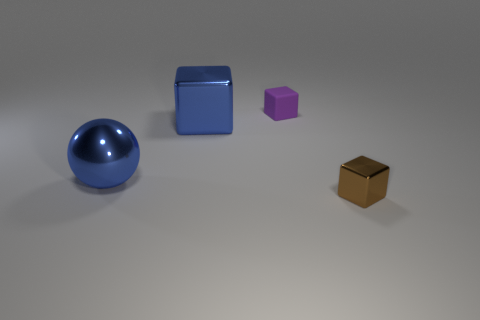Add 2 small cyan cubes. How many objects exist? 6 Subtract all large blocks. How many blocks are left? 2 Subtract 2 cubes. How many cubes are left? 1 Subtract all purple cubes. How many cubes are left? 2 Subtract all cubes. How many objects are left? 1 Subtract all cyan cubes. Subtract all gray cylinders. How many cubes are left? 3 Subtract all yellow cubes. How many purple spheres are left? 0 Subtract all brown shiny things. Subtract all blue spheres. How many objects are left? 2 Add 3 large metal balls. How many large metal balls are left? 4 Add 1 tiny yellow metal cubes. How many tiny yellow metal cubes exist? 1 